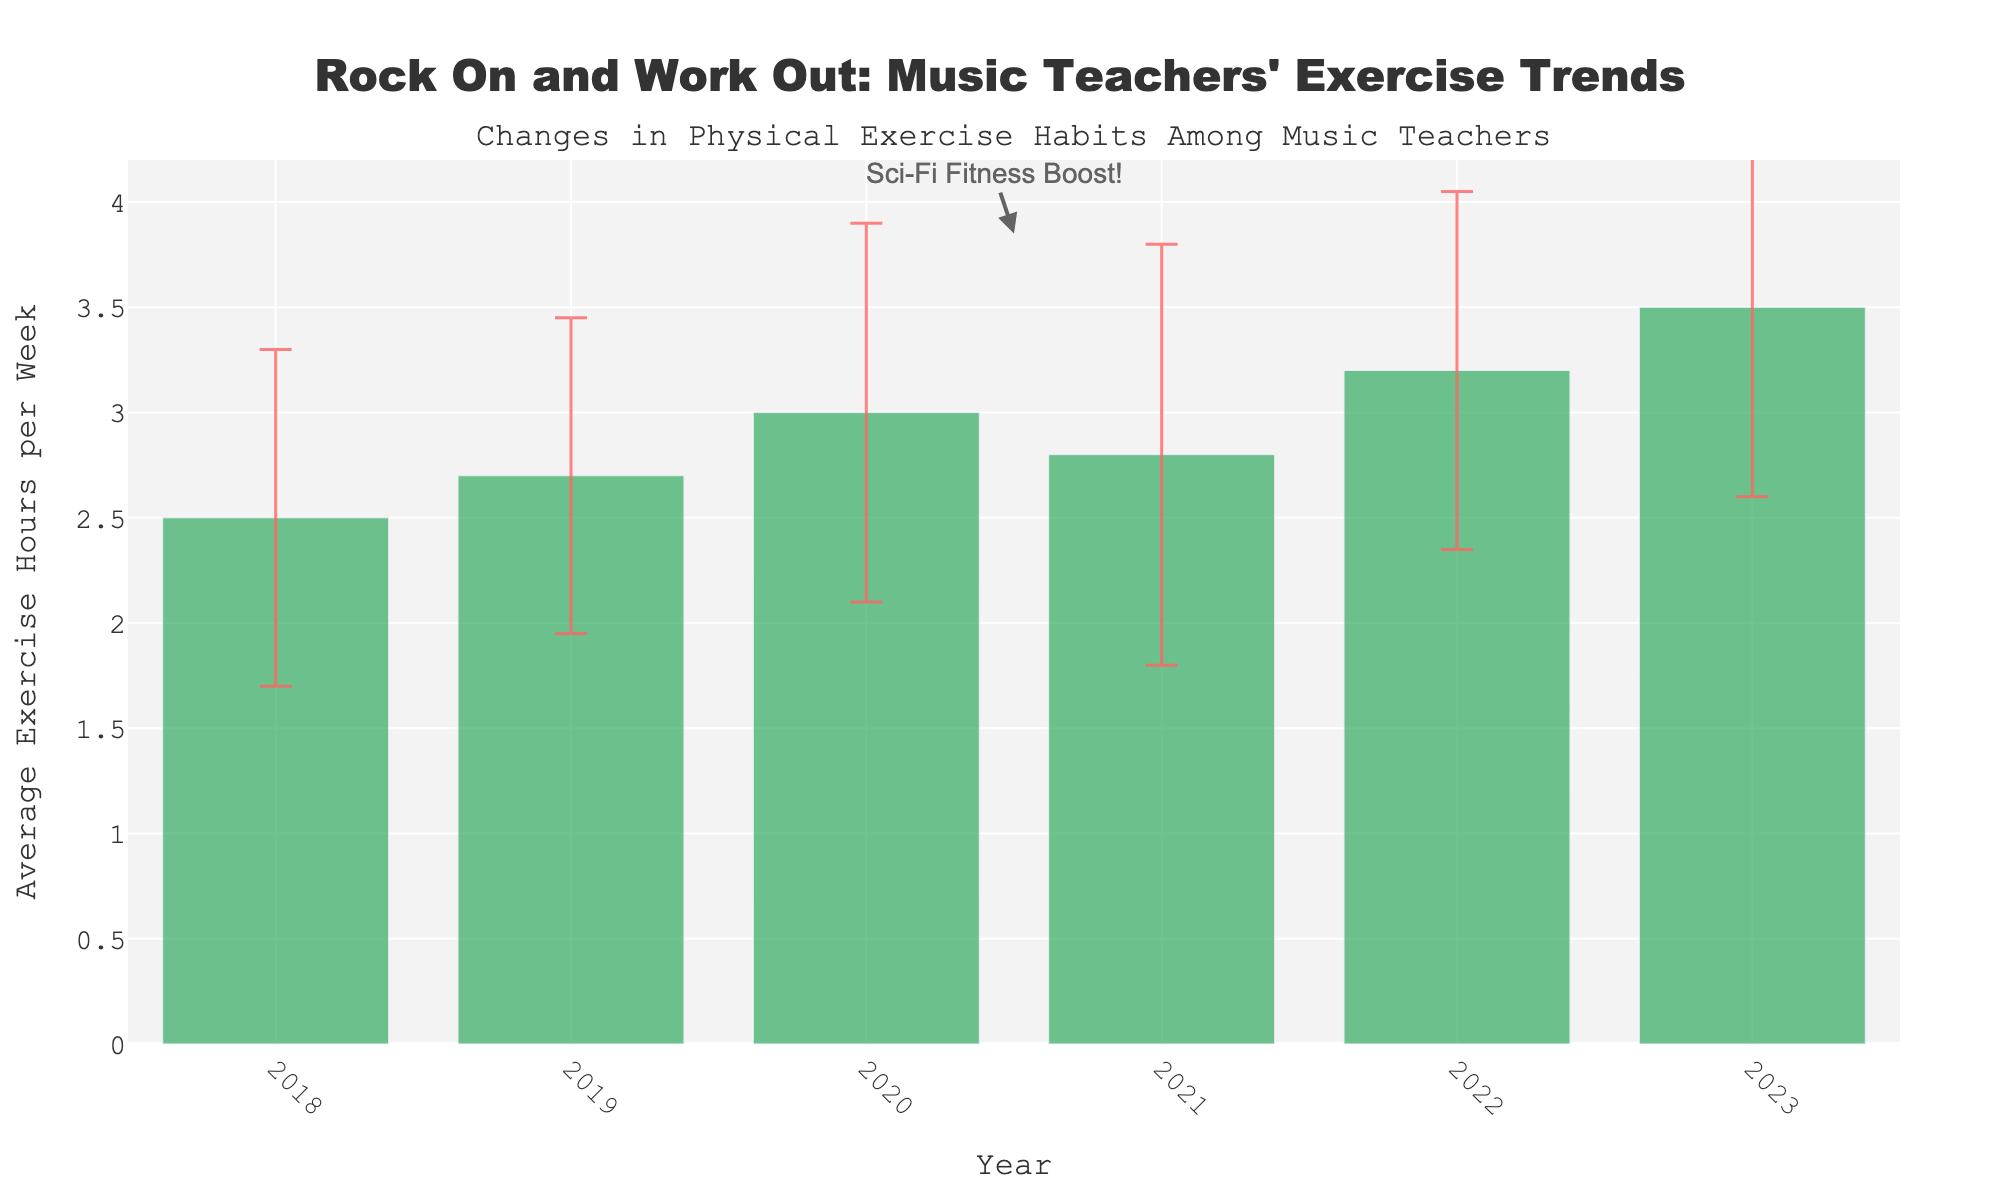What is the title of the plot? The title is located at the top of the plot and reads "Rock On and Work Out: Music Teachers' Exercise Trends".
Answer: "Rock On and Work Out: Music Teachers' Exercise Trends" How many years are displayed on the x-axis? The x-axis of the plot shows individual years, and by counting them, we see the years 2018 to 2023, so there are six distinct years displayed.
Answer: Six What was the average exercise hours per week in 2020? By looking at the bar corresponding to 2020, we can see that the average exercise hours per week are 3.0.
Answer: 3.0 Which year had the highest average exercise hours per week? The highest bar corresponds to the year 2023, indicating that it had the highest average exercise hours per week.
Answer: 2023 What is the range of the y-axis? The y-axis starts at 0 and ends at a value slightly above 3.5, approximately 4.2, based on visual inspection.
Answer: 0 to ~4.2 Has there been any year where the average exercise hours per week decreased compared to the previous year? If yes, which year? Observing the bars year by year, the only decrease occurs from 2020 (3.0 hours) to 2021 (2.8 hours).
Answer: 2021 What is the trend in average exercise hours per week from 2018 to 2023? Starting from 2018's 2.5 hours, the overall trend is upward, with a slight dip in 2021 but increasing again and peaking at 3.5 hours in 2023.
Answer: Increasing trend Which year has the largest standard deviation in exercise hours per week? The size of the error bar represents the standard deviation. The 2021 bar shows the largest error bar, indicating the highest standard deviation.
Answer: 2021 What event is indicated by the annotation, and which years are closest to that annotation? The annotation "Sci-Fi Fitness Boost!" is closest to the years 2020 and 2021 as it is placed between these two bars.
Answer: "Sci-Fi Fitness Boost!" between 2020 and 2021 What's the difference in average exercise hours per week between 2019 and 2023? The average exercise hours per week in 2019 is 2.7 and in 2023 is 3.5. The difference is calculated as 3.5 - 2.7 = 0.8 hours.
Answer: 0.8 hours 